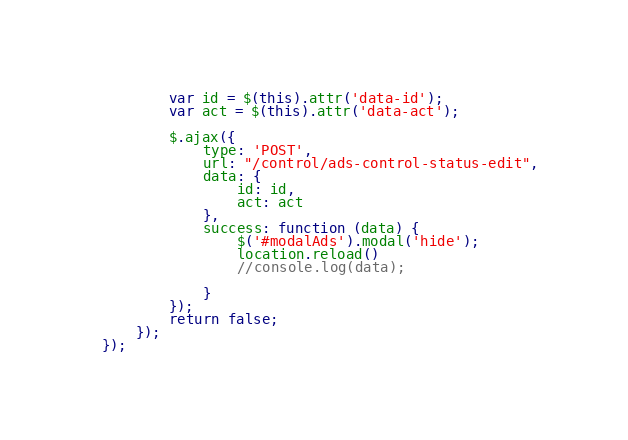<code> <loc_0><loc_0><loc_500><loc_500><_JavaScript_>        var id = $(this).attr('data-id');
        var act = $(this).attr('data-act');

        $.ajax({
            type: 'POST',
            url: "/control/ads-control-status-edit",
            data: {
                id: id,
                act: act
            },
            success: function (data) {
                $('#modalAds').modal('hide');
                location.reload()
                //console.log(data);

            }
        });
        return false;
    });
});
</code> 